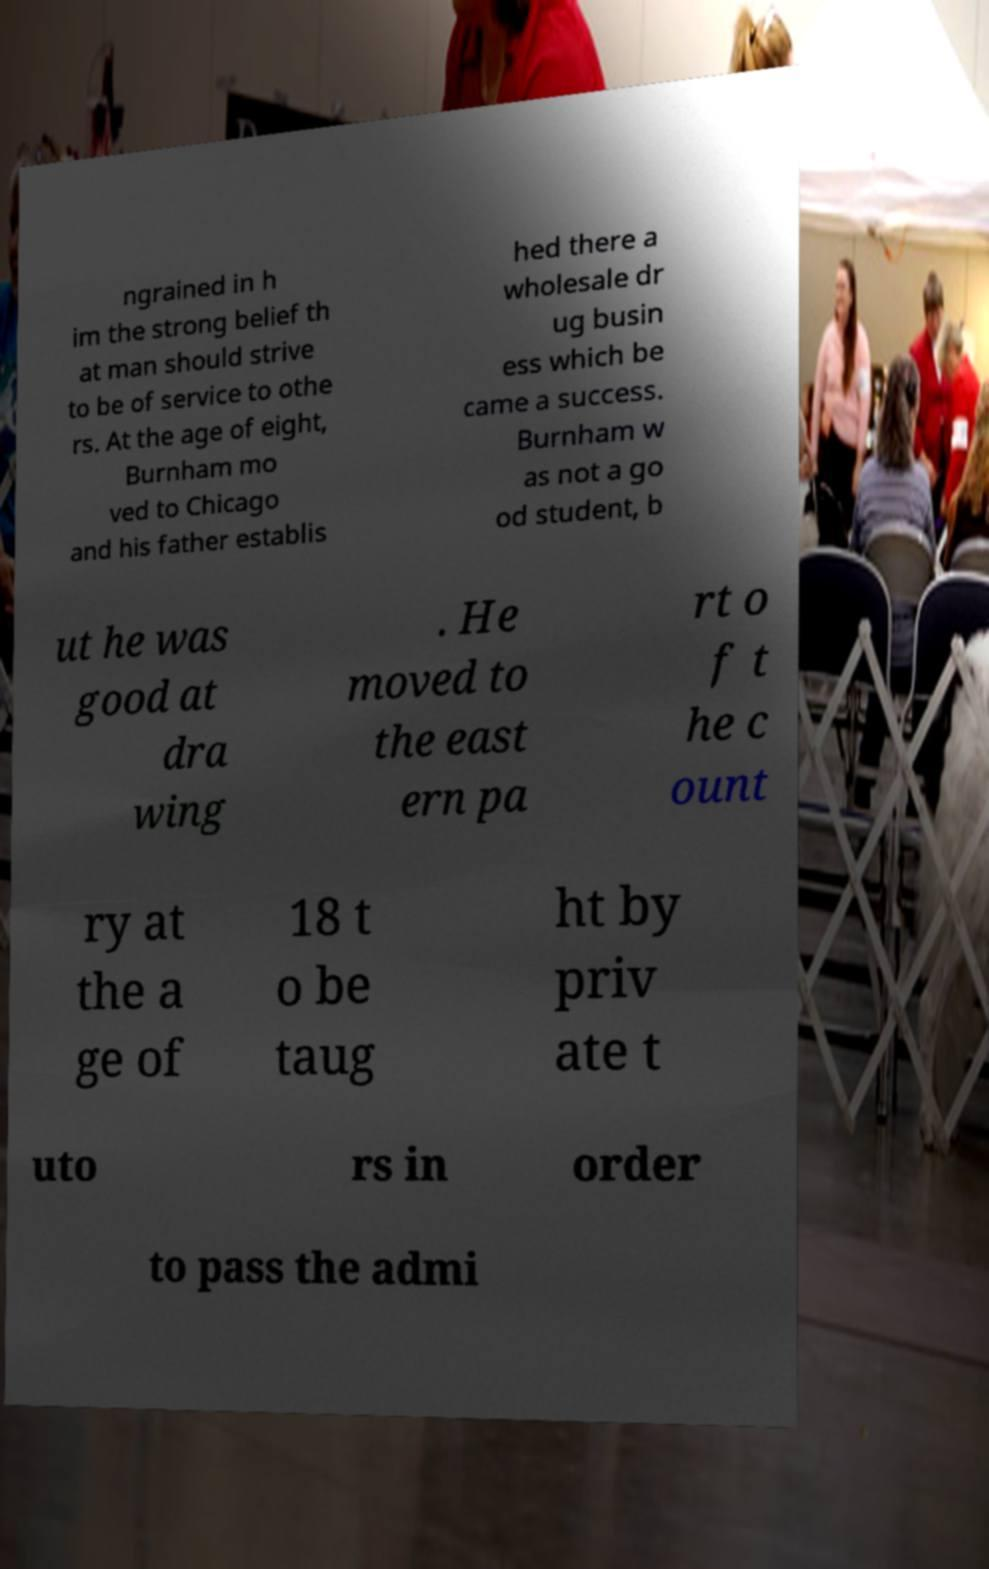Please read and relay the text visible in this image. What does it say? ngrained in h im the strong belief th at man should strive to be of service to othe rs. At the age of eight, Burnham mo ved to Chicago and his father establis hed there a wholesale dr ug busin ess which be came a success. Burnham w as not a go od student, b ut he was good at dra wing . He moved to the east ern pa rt o f t he c ount ry at the a ge of 18 t o be taug ht by priv ate t uto rs in order to pass the admi 